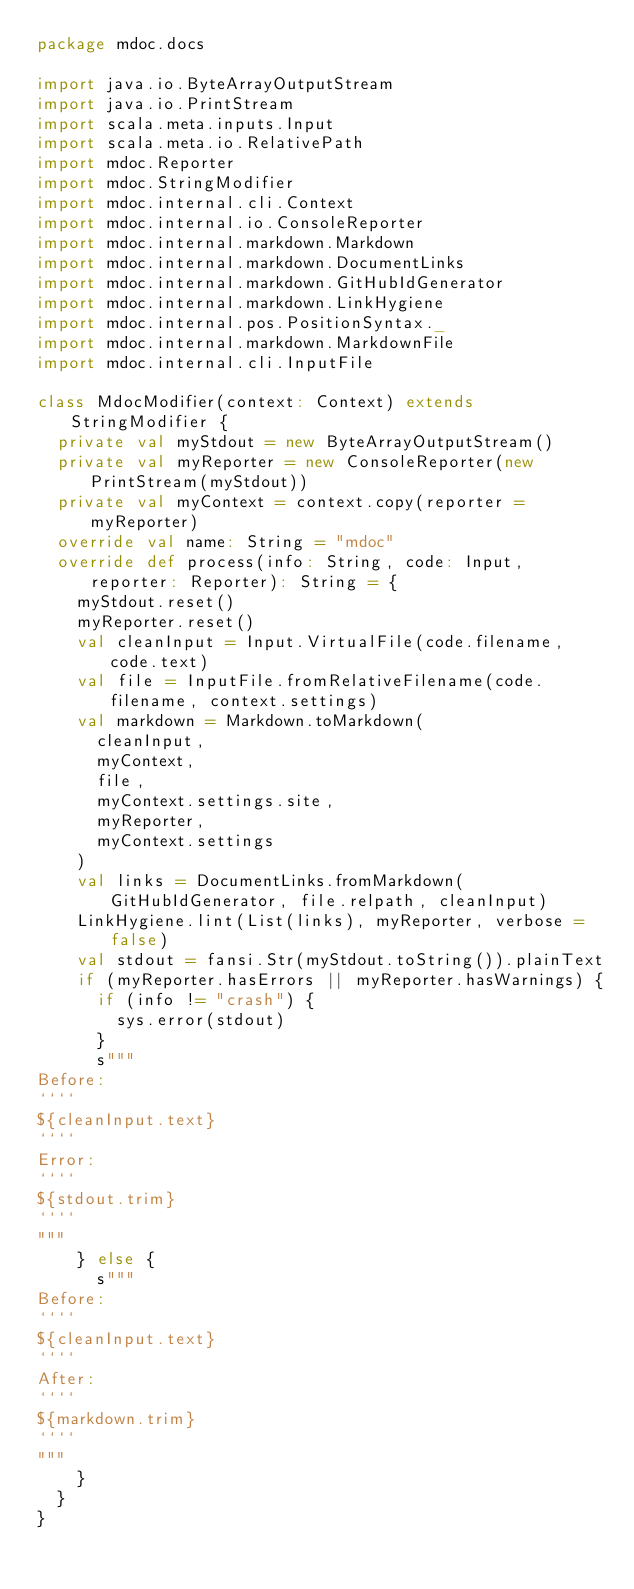<code> <loc_0><loc_0><loc_500><loc_500><_Scala_>package mdoc.docs

import java.io.ByteArrayOutputStream
import java.io.PrintStream
import scala.meta.inputs.Input
import scala.meta.io.RelativePath
import mdoc.Reporter
import mdoc.StringModifier
import mdoc.internal.cli.Context
import mdoc.internal.io.ConsoleReporter
import mdoc.internal.markdown.Markdown
import mdoc.internal.markdown.DocumentLinks
import mdoc.internal.markdown.GitHubIdGenerator
import mdoc.internal.markdown.LinkHygiene
import mdoc.internal.pos.PositionSyntax._
import mdoc.internal.markdown.MarkdownFile
import mdoc.internal.cli.InputFile

class MdocModifier(context: Context) extends StringModifier {
  private val myStdout = new ByteArrayOutputStream()
  private val myReporter = new ConsoleReporter(new PrintStream(myStdout))
  private val myContext = context.copy(reporter = myReporter)
  override val name: String = "mdoc"
  override def process(info: String, code: Input, reporter: Reporter): String = {
    myStdout.reset()
    myReporter.reset()
    val cleanInput = Input.VirtualFile(code.filename, code.text)
    val file = InputFile.fromRelativeFilename(code.filename, context.settings)
    val markdown = Markdown.toMarkdown(
      cleanInput,
      myContext,
      file,
      myContext.settings.site,
      myReporter,
      myContext.settings
    )
    val links = DocumentLinks.fromMarkdown(GitHubIdGenerator, file.relpath, cleanInput)
    LinkHygiene.lint(List(links), myReporter, verbose = false)
    val stdout = fansi.Str(myStdout.toString()).plainText
    if (myReporter.hasErrors || myReporter.hasWarnings) {
      if (info != "crash") {
        sys.error(stdout)
      }
      s"""
Before:
````
${cleanInput.text}
````
Error:
````
${stdout.trim}
````
"""
    } else {
      s"""
Before:
````
${cleanInput.text}
````
After:
````
${markdown.trim}
````
"""
    }
  }
}
</code> 